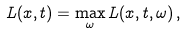Convert formula to latex. <formula><loc_0><loc_0><loc_500><loc_500>L ( x , t ) = \max _ { \omega } L ( x , t , \omega ) \, ,</formula> 